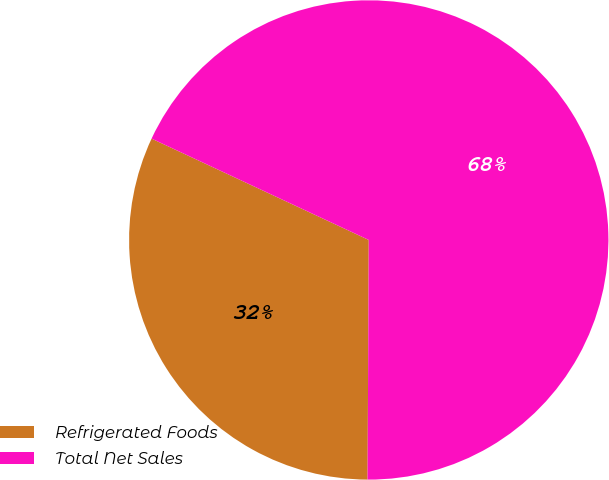<chart> <loc_0><loc_0><loc_500><loc_500><pie_chart><fcel>Refrigerated Foods<fcel>Total Net Sales<nl><fcel>31.87%<fcel>68.13%<nl></chart> 